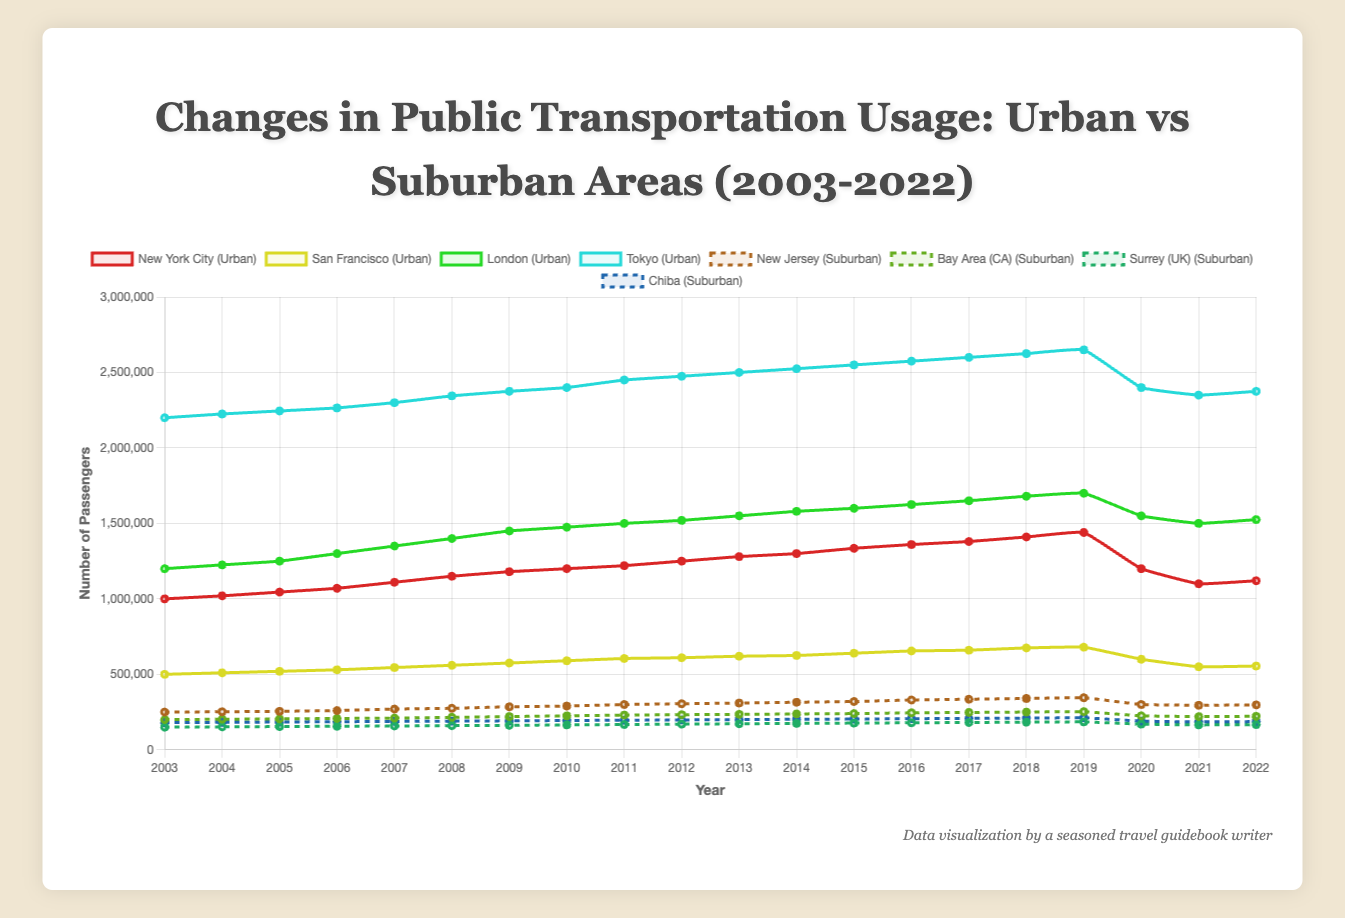What is the general trend in public transportation usage for Tokyo from 2003 to 2022? The general trend can be identified by observing the slope of the line representing Tokyo. From 2003 to 2019, we see an increasing trend in usage, but there's a noticeable drop in 2020 followed by a slight recovery.
Answer: Increasing until 2019, then a drop and slight recovery How did public transportation usage in urban areas change in 2020 compared to 2019? For Tokyo, New York City, London, and San Francisco, observe the changes in their respective line plots between 2019 and 2020. All four cities show a sharp decline in usage in 2020.
Answer: Decreased Which urban city had the highest number of public transportation users in 2010? Look at the data points for 2010 for Tokyo, New York City, London, and San Francisco. Tokyo has the highest value at 2,400,000 passengers.
Answer: Tokyo Between New Jersey and the Bay Area, which suburban location had a higher number of passengers in 2021? Compare the data for 2021 for New Jersey and the Bay Area. A visual inspection shows that New Jersey had 295,000 passengers compared to the Bay Area's 220,000.
Answer: New Jersey What is the difference in public transportation usage between New York City and London in 2017? Identify the data points for New York City and London in 2017. For New York City, it's 1,380,000, and for London, it's 1,650,000. The difference is 1,650,000 - 1,380,000 = 270,000.
Answer: 270,000 Which location experienced the most significant drop in public transportation usage in 2020? Compare the differences between 2019 and 2020 for all locations. Tokyo shows the largest drop from 2,650,000 to 2,400,000, a decline of 250,000.
Answer: Tokyo Compare the number of passengers in New York City in 2022 to its number in 2003. How much has it increased? Identify the data for New York City in 2003 and 2022. The values are 1,000,000 in 2003 and 1,120,000 in 2022. The increase is 1,120,000 - 1,000,000 = 120,000.
Answer: 120,000 What was the highest passenger number reached by San Francisco during the 20-year period, and in which year did this occur? Check the highest value in the San Francisco series. The highest is 680,000, which occurred in 2019.
Answer: 680,000 in 2019 Which suburban area had the least number of passengers in 2010? Look at the values for New Jersey, Bay Area, Surrey, and Chiba for 2010. The lowest value is in Surrey with 165,000 passengers.
Answer: Surrey 